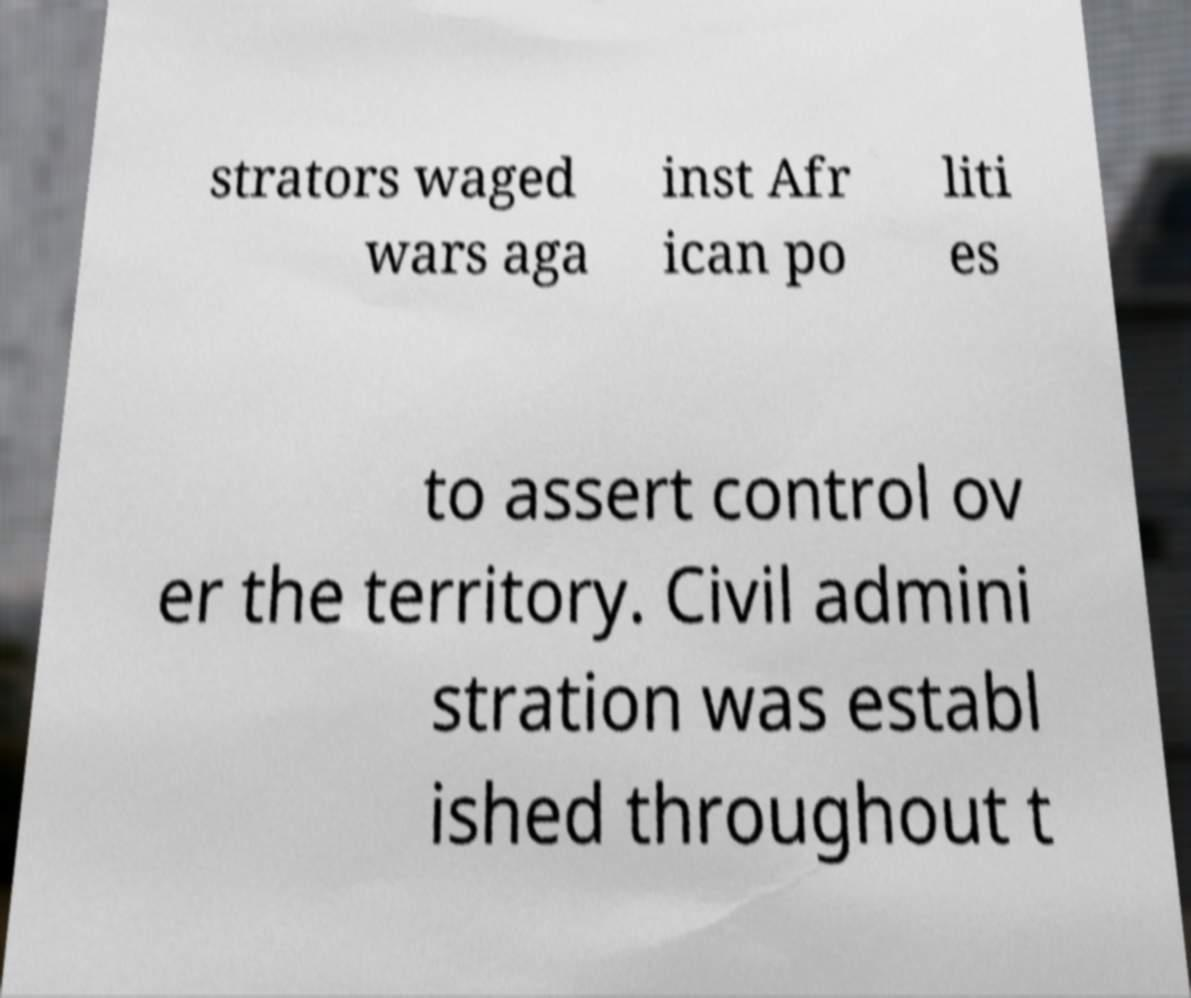Please identify and transcribe the text found in this image. strators waged wars aga inst Afr ican po liti es to assert control ov er the territory. Civil admini stration was establ ished throughout t 